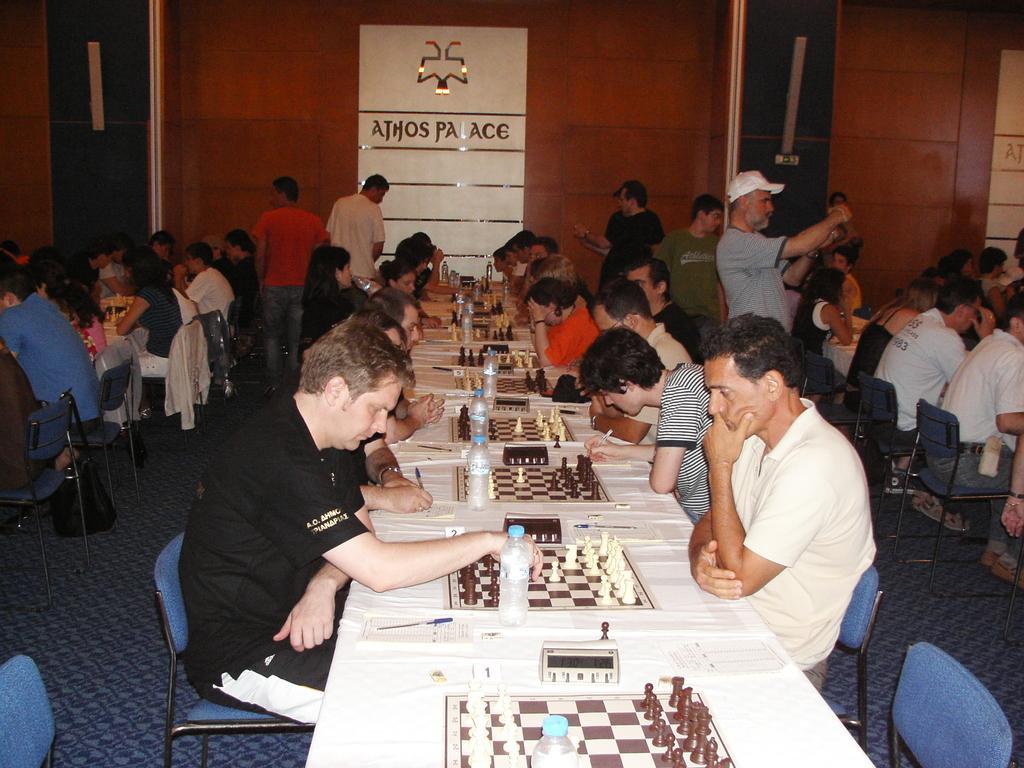How would you summarize this image in a sentence or two? In this image I can see number of people of people are sitting on chairs and also few of them are standing. On these tables I can see chess boards and few bottles 